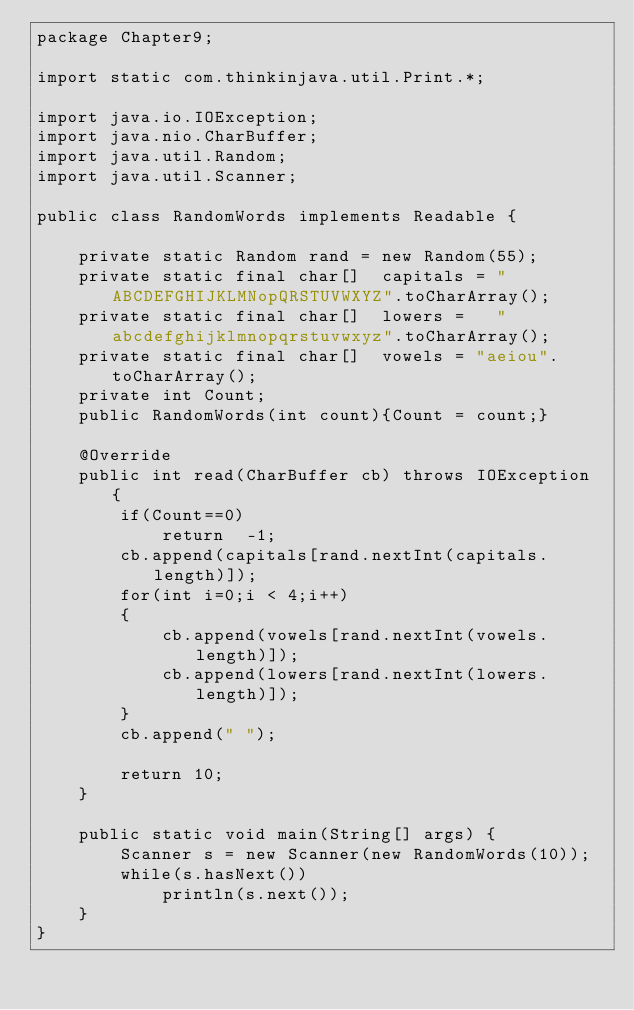Convert code to text. <code><loc_0><loc_0><loc_500><loc_500><_Java_>package Chapter9;

import static com.thinkinjava.util.Print.*;

import java.io.IOException;
import java.nio.CharBuffer;
import java.util.Random;
import java.util.Scanner;

public class RandomWords implements Readable {

    private static Random rand = new Random(55);
    private static final char[]  capitals = "ABCDEFGHIJKLMNopQRSTUVWXYZ".toCharArray();
    private static final char[]  lowers =   "abcdefghijklmnopqrstuvwxyz".toCharArray();
    private static final char[]  vowels = "aeiou".toCharArray();
    private int Count;
    public RandomWords(int count){Count = count;}

    @Override
    public int read(CharBuffer cb) throws IOException {
        if(Count==0)
            return  -1;
        cb.append(capitals[rand.nextInt(capitals.length)]);
        for(int i=0;i < 4;i++)
        {
            cb.append(vowels[rand.nextInt(vowels.length)]);
            cb.append(lowers[rand.nextInt(lowers.length)]);
        }
        cb.append(" ");

        return 10;
    }

    public static void main(String[] args) {
        Scanner s = new Scanner(new RandomWords(10));
        while(s.hasNext())
            println(s.next());
    }
}
</code> 